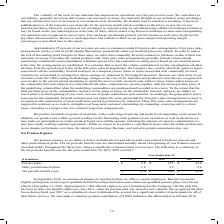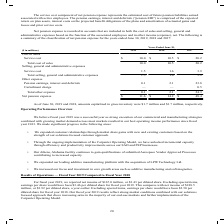According to Carpenter Technology's financial document, What does net pension expense include? includes the net periodic benefit costs related to both our pension and other postretirement plans.. The document states: "Net pension expense, as we define it below, includes the net periodic benefit costs related to both our pension and other postretirement plans. The ne..." Also, When was the changes to retirement plans offered to certain employees announced? According to the financial document, In September 2016. The relevant text states: "In September 2016, we announced changes to retirement plans we offer to certain employees. Benefits accrued to eligib..." Also, In which years was Net Pension Expense calculated? The document contains multiple relevant values: 2019, 2018, 2017. From the document: "($ in millions) 2019 2018 2017 Pension plans $ 9.8 $ 11.3 $ 45.8 Other postretirement plans 1.8 2.9 2.6 Net periodic benefit costs ($ in millions) 201..." Additionally, In which year was Other postretirement plans largest? According to the financial document, 2018. The relevant text states: "($ in millions) 2019 2018 2017 Pension plans $ 9.8 $ 11.3 $ 45.8 Other postretirement plans 1.8 2.9 2.6 Net periodic benefit..." Also, can you calculate: What was the change in Pension Plans in 2019 from 2018? Based on the calculation: 9.8-11.3, the result is -1.5 (in millions). This is based on the information: "($ in millions) 2019 2018 2017 Pension plans $ 9.8 $ 11.3 $ 45.8 Other postretirement plans 1.8 2.9 2.6 Net periodic benefit costs $ 11.6 $ 14.2 $ 48. in millions) 2019 2018 2017 Pension plans $ 9.8 $..." The key data points involved are: 11.3, 9.8. Also, can you calculate: What was the percentage change in Pension Plans in 2019 from 2018? To answer this question, I need to perform calculations using the financial data. The calculation is: (9.8-11.3)/11.3, which equals -13.27 (percentage). This is based on the information: "($ in millions) 2019 2018 2017 Pension plans $ 9.8 $ 11.3 $ 45.8 Other postretirement plans 1.8 2.9 2.6 Net periodic benefit costs $ 11.6 $ 14.2 $ 48. in millions) 2019 2018 2017 Pension plans $ 9.8 $..." The key data points involved are: 11.3, 9.8. 